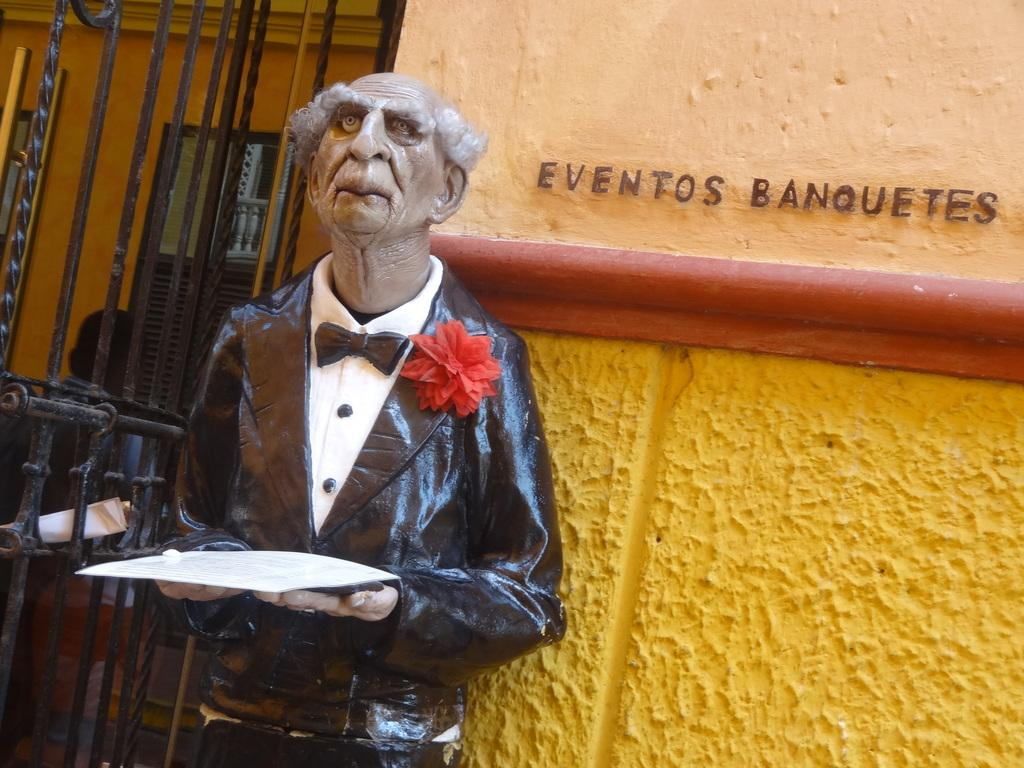What is the main subject of the image? There is a statue in the image. What is the statue wearing? The statue is wearing a black dress. What is the statue holding in its hand? The statue is holding an object in its hand. What is located near the statue? There is a fence gate beside the statue. What can be seen on the wall behind the statue? There is something written on the wall behind the statue. Where is the sink located in the image? There is no sink present in the image. Is there a bear interacting with the statue in the image? There is no bear present in the image. 